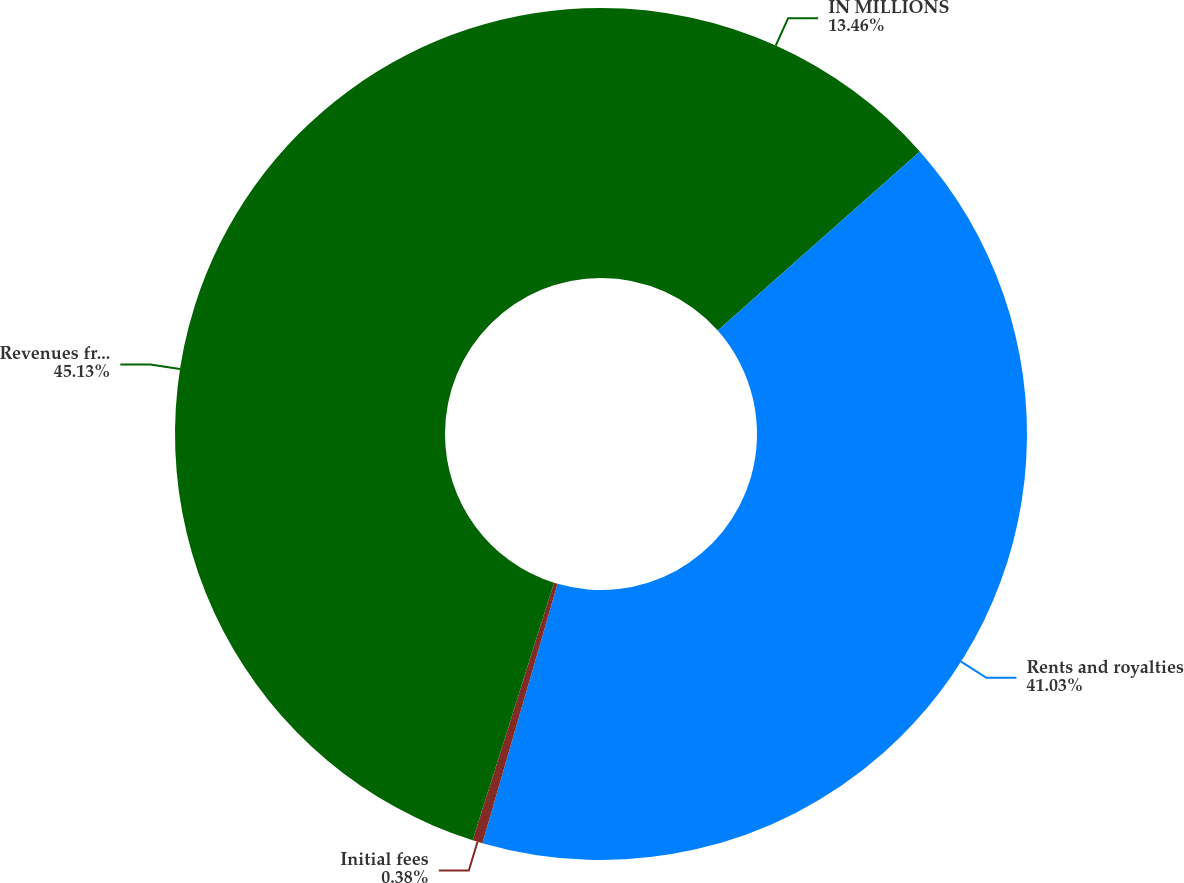Convert chart. <chart><loc_0><loc_0><loc_500><loc_500><pie_chart><fcel>IN MILLIONS<fcel>Rents and royalties<fcel>Initial fees<fcel>Revenues from franchised and<nl><fcel>13.46%<fcel>41.03%<fcel>0.38%<fcel>45.13%<nl></chart> 